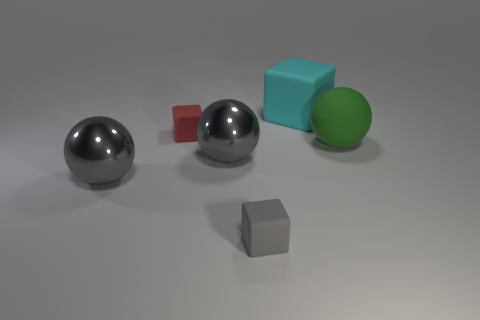How are the shadows affecting the perception of the objects? The shadows cast by the objects contribute to the perception of their three-dimensionality. The soft shadows indicate a diffused light source, enhancing the realism of the scene and providing clues about the position and size of each object relative to the light source. 